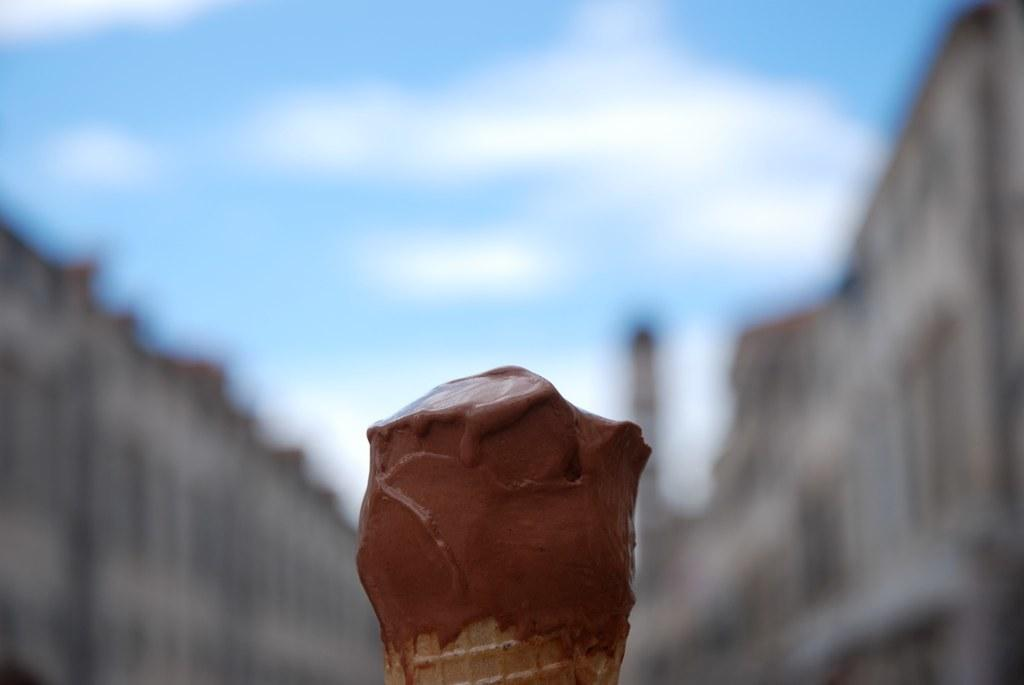What color is the ice cream in the image? The ice cream is brown colored in the image. What is the ice cream placed on? The ice cream is on an object. What can be seen in the distance in the image? There are buildings in the background of the image. What is visible in the sky in the background of the image? There are clouds in the sky in the background of the image. How many fingers are holding the ice cream in the image? There are no fingers visible in the image; the ice cream is on an object. 